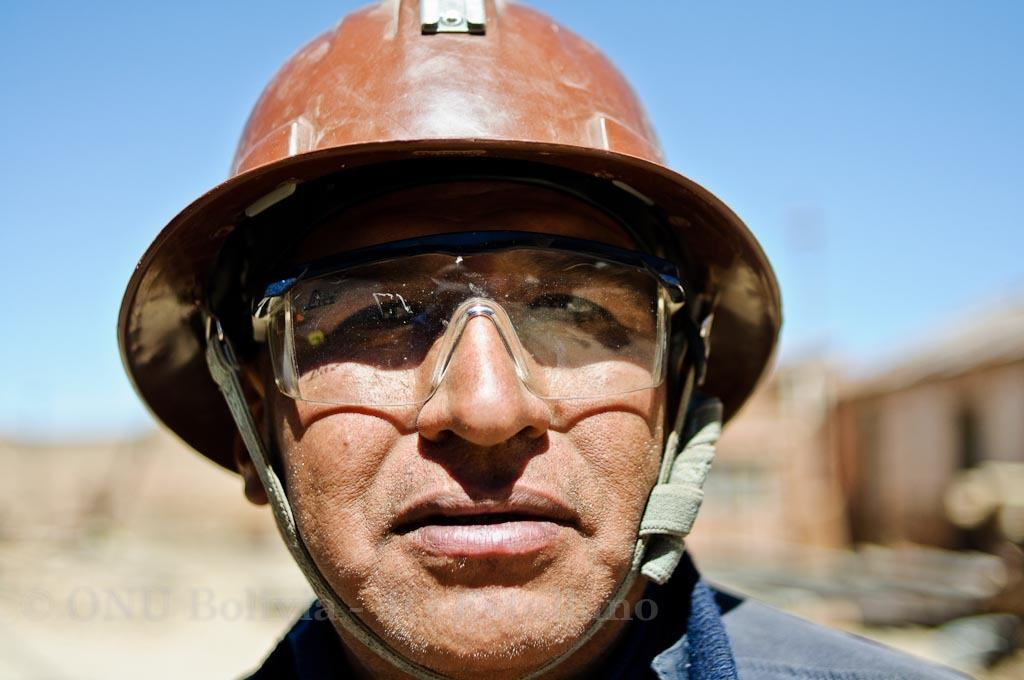What is the main subject of the picture? The main subject of the picture is a man. What protective gear is the man wearing? The man is wearing a helmet and goggles. What type of clothing is the man wearing on his upper body? The man is wearing a shirt. What can be seen on the right side of the image? There is a building at the right side of the image. What is present in the bottom left of the image? There is a watermark in the bottom left of the image. What part of the natural environment is visible in the image? The sky is visible in the top right of the image. What type of nail is the man using to fix the neck of the son in the image? There is no nail, neck, or son present in the image. 